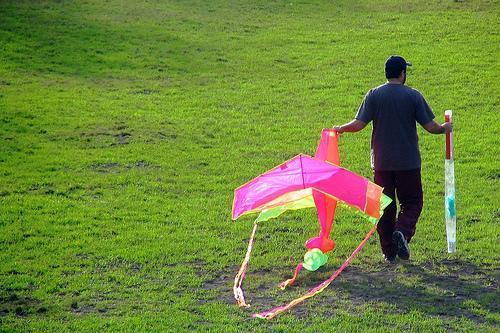How many people are pictured here?
Give a very brief answer. 1. 